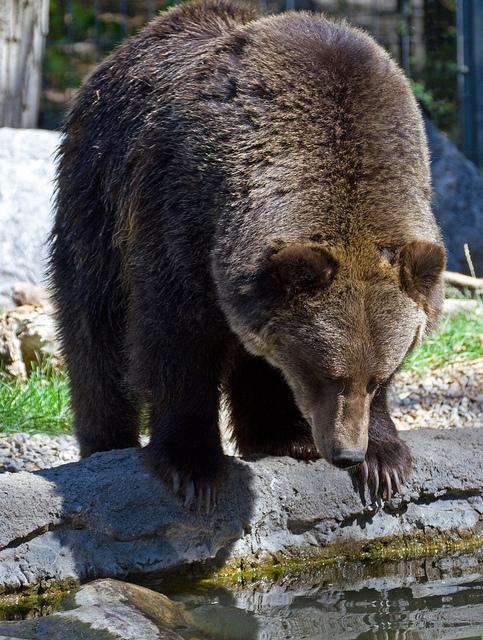How many double decker buses are in this scene?
Give a very brief answer. 0. 